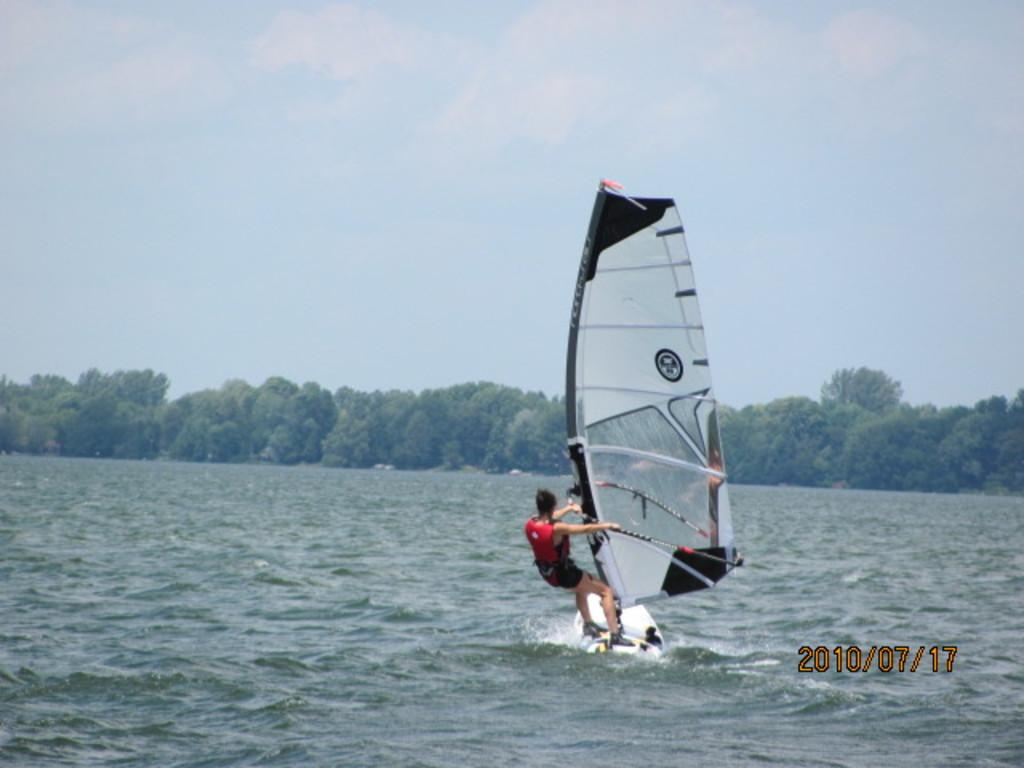Who is the main subject in the image? There is a man in the image. What is the man doing in the image? The man is windsurfing on the water. What can be seen in the background of the image? There are trees and the sky visible in the image. Is there any additional information about the image itself? Yes, there is a watermark on the image. What type of drink is the queen holding in the image? There is no queen or drink present in the image; it features a man windsurfing on the water. How far away is the nearest landmark from the man in the image? The provided facts do not give any information about the distance to the nearest landmark, so it cannot be determined from the image. 